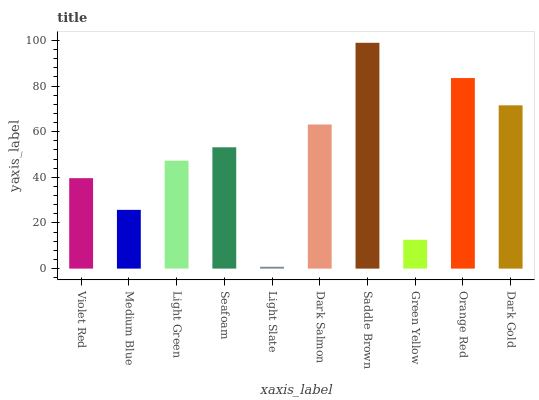Is Light Slate the minimum?
Answer yes or no. Yes. Is Saddle Brown the maximum?
Answer yes or no. Yes. Is Medium Blue the minimum?
Answer yes or no. No. Is Medium Blue the maximum?
Answer yes or no. No. Is Violet Red greater than Medium Blue?
Answer yes or no. Yes. Is Medium Blue less than Violet Red?
Answer yes or no. Yes. Is Medium Blue greater than Violet Red?
Answer yes or no. No. Is Violet Red less than Medium Blue?
Answer yes or no. No. Is Seafoam the high median?
Answer yes or no. Yes. Is Light Green the low median?
Answer yes or no. Yes. Is Medium Blue the high median?
Answer yes or no. No. Is Violet Red the low median?
Answer yes or no. No. 